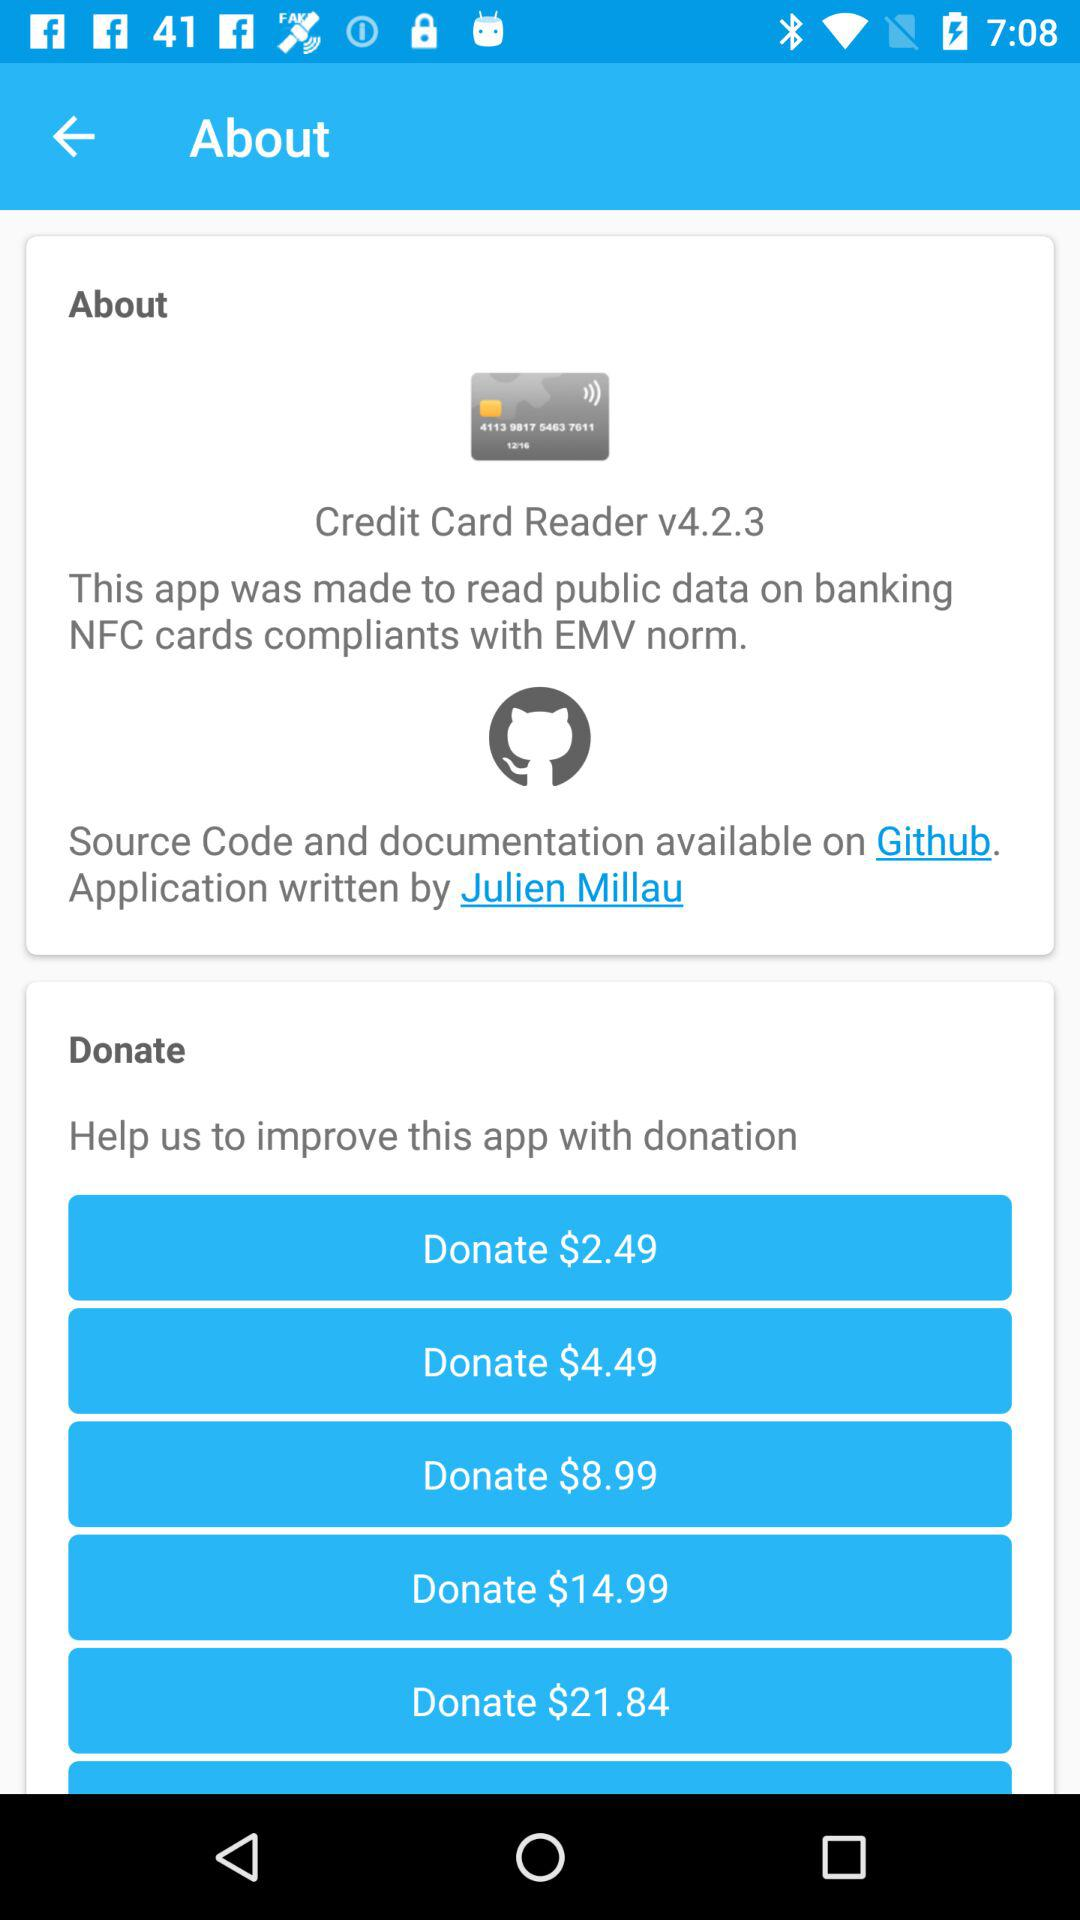What is the version of the application? The version of the application is v4.2.3. 